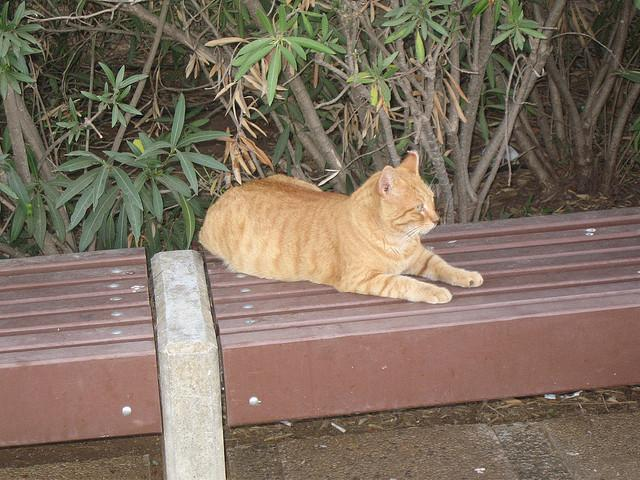What word describes this animal? cat 